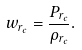Convert formula to latex. <formula><loc_0><loc_0><loc_500><loc_500>w _ { r _ { c } } = \frac { P _ { r _ { c } } } { \rho _ { r _ { c } } } .</formula> 